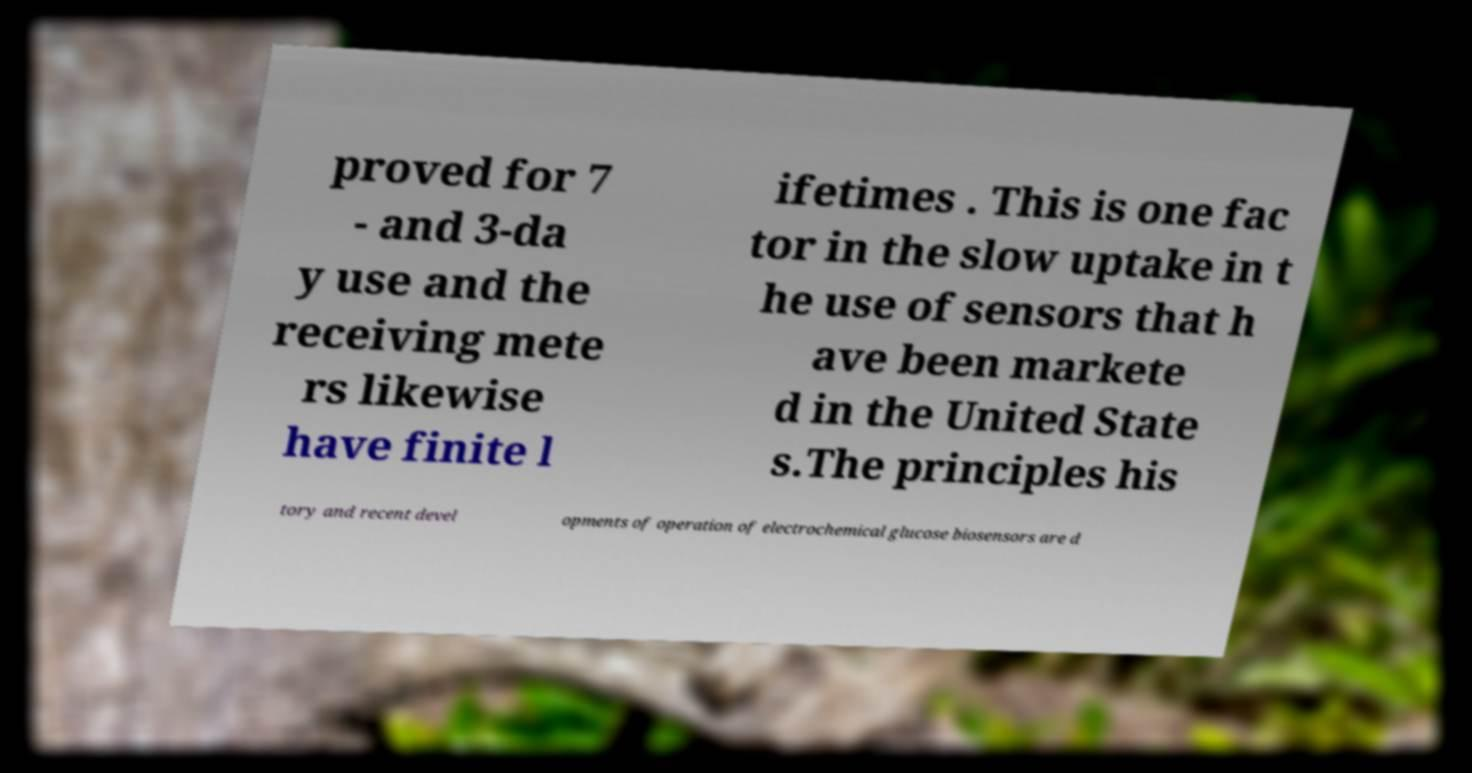There's text embedded in this image that I need extracted. Can you transcribe it verbatim? proved for 7 - and 3-da y use and the receiving mete rs likewise have finite l ifetimes . This is one fac tor in the slow uptake in t he use of sensors that h ave been markete d in the United State s.The principles his tory and recent devel opments of operation of electrochemical glucose biosensors are d 